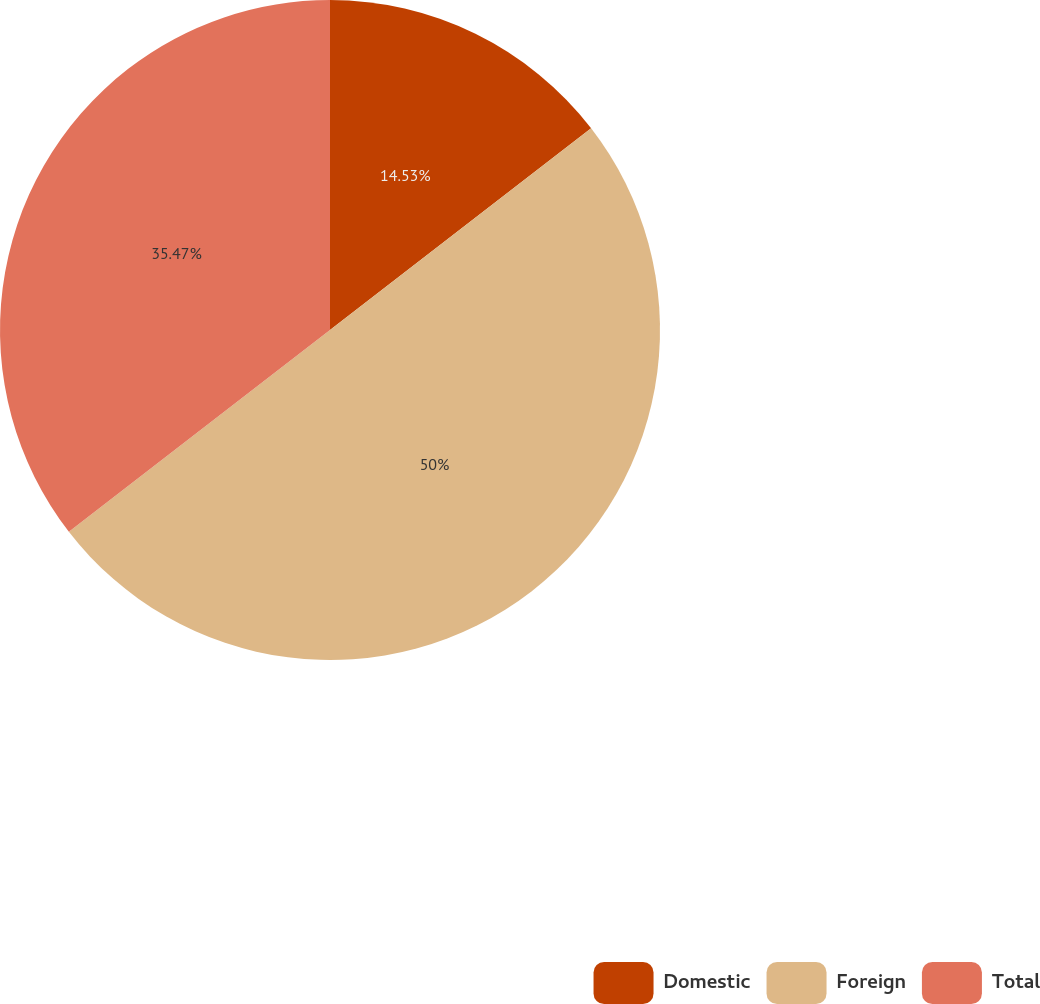Convert chart. <chart><loc_0><loc_0><loc_500><loc_500><pie_chart><fcel>Domestic<fcel>Foreign<fcel>Total<nl><fcel>14.53%<fcel>50.0%<fcel>35.47%<nl></chart> 